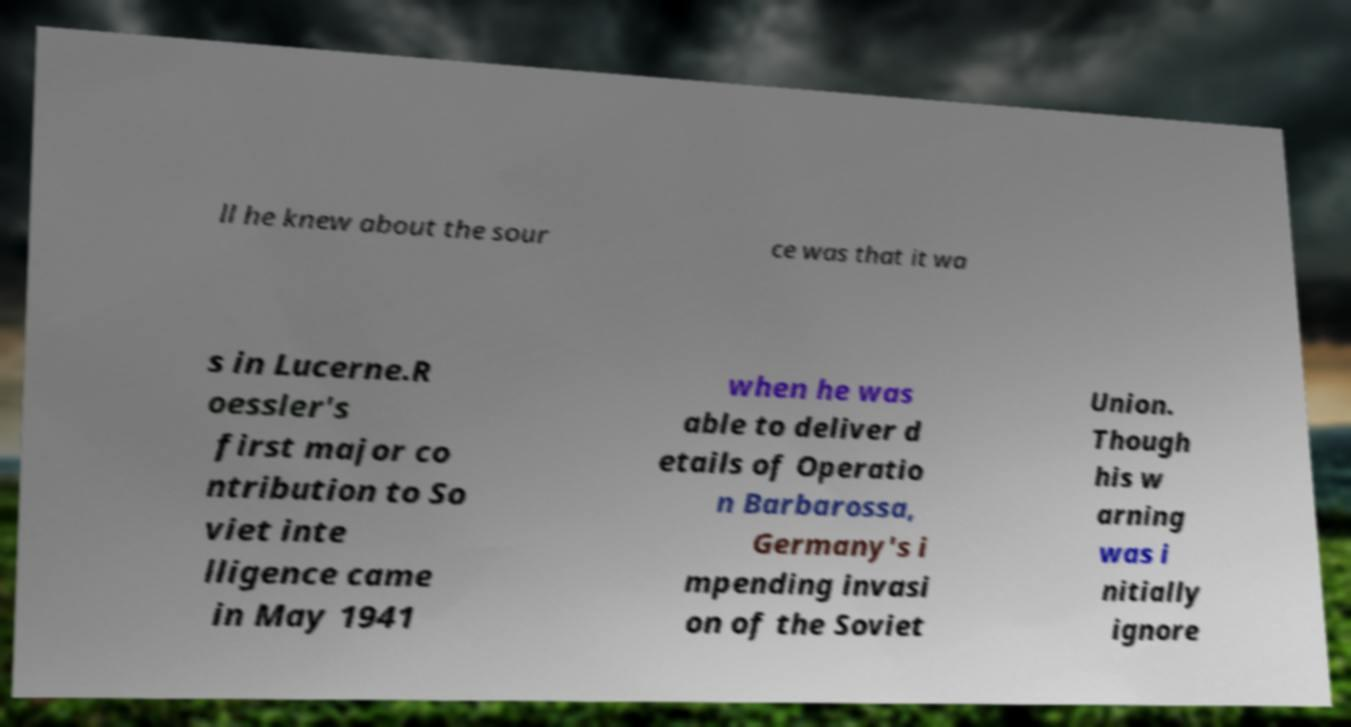Can you read and provide the text displayed in the image?This photo seems to have some interesting text. Can you extract and type it out for me? ll he knew about the sour ce was that it wa s in Lucerne.R oessler's first major co ntribution to So viet inte lligence came in May 1941 when he was able to deliver d etails of Operatio n Barbarossa, Germany's i mpending invasi on of the Soviet Union. Though his w arning was i nitially ignore 